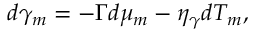<formula> <loc_0><loc_0><loc_500><loc_500>d \gamma _ { m } = - \Gamma d \mu _ { m } - \eta _ { \gamma } d T _ { m } ,</formula> 